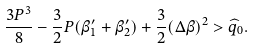Convert formula to latex. <formula><loc_0><loc_0><loc_500><loc_500>\frac { 3 P ^ { 3 } } { 8 } - \frac { 3 } { 2 } P ( \beta _ { 1 } ^ { \prime } + \beta _ { 2 } ^ { \prime } ) + \frac { 3 } { 2 } ( \Delta \beta ) ^ { 2 } > \widehat { q } _ { 0 } .</formula> 